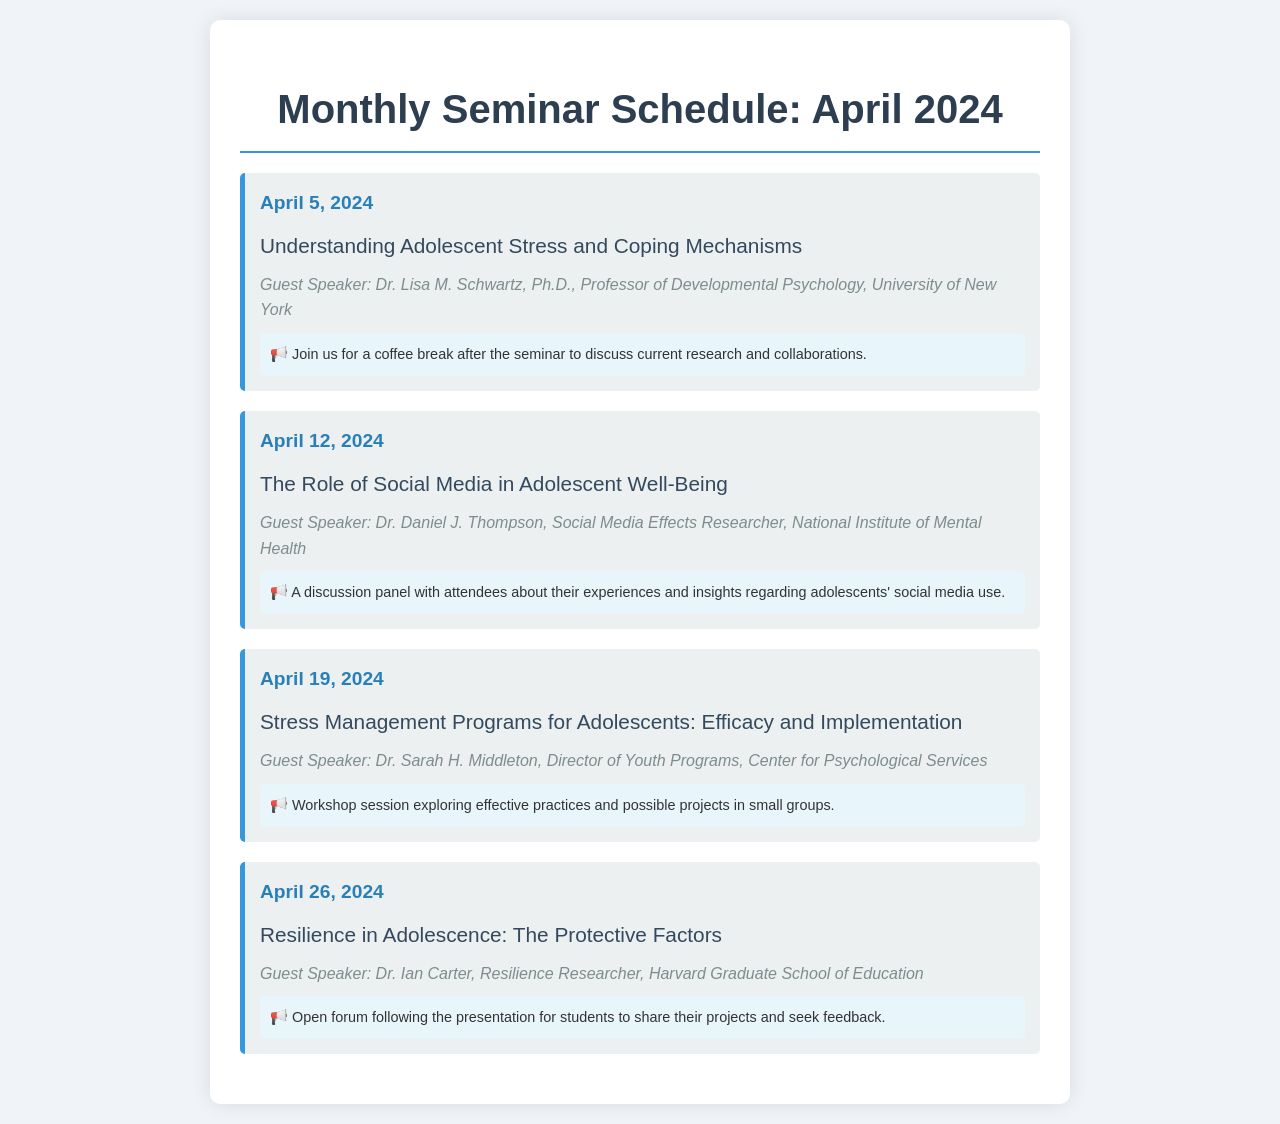What is the topic of the seminar on April 5, 2024? The topic of the seminar can be found in the details, specifically for April 5.
Answer: Understanding Adolescent Stress and Coping Mechanisms Who is the guest speaker for the seminar on April 12, 2024? The name of the guest speaker is mentioned in the April 12 seminar details.
Answer: Dr. Daniel J. Thompson What networking opportunity follows the seminar on April 19, 2024? The networking opportunity is specifically tied to the seminar content for the date April 19.
Answer: Workshop session exploring effective practices and possible projects in small groups How many seminars are scheduled for April 2024? The total number of seminars can be counted from the list provided in the document.
Answer: 4 What is the main theme of the seminar series? The overarching theme can be inferred from the individual topics scheduled for each seminar.
Answer: Adolescent Stress What is the date of the last seminar in April 2024? The date is provided in the details of the last seminar listed.
Answer: April 26, 2024 Who is the guest speaker for the seminar discussing resilience? The guest speaker's name is specifically mentioned for the seminar on resilience in adolescence.
Answer: Dr. Ian Carter What is the focus of the seminar on April 19, 2024? The focus of the seminar can be found in the topic description for that date.
Answer: Stress Management Programs for Adolescents: Efficacy and Implementation 